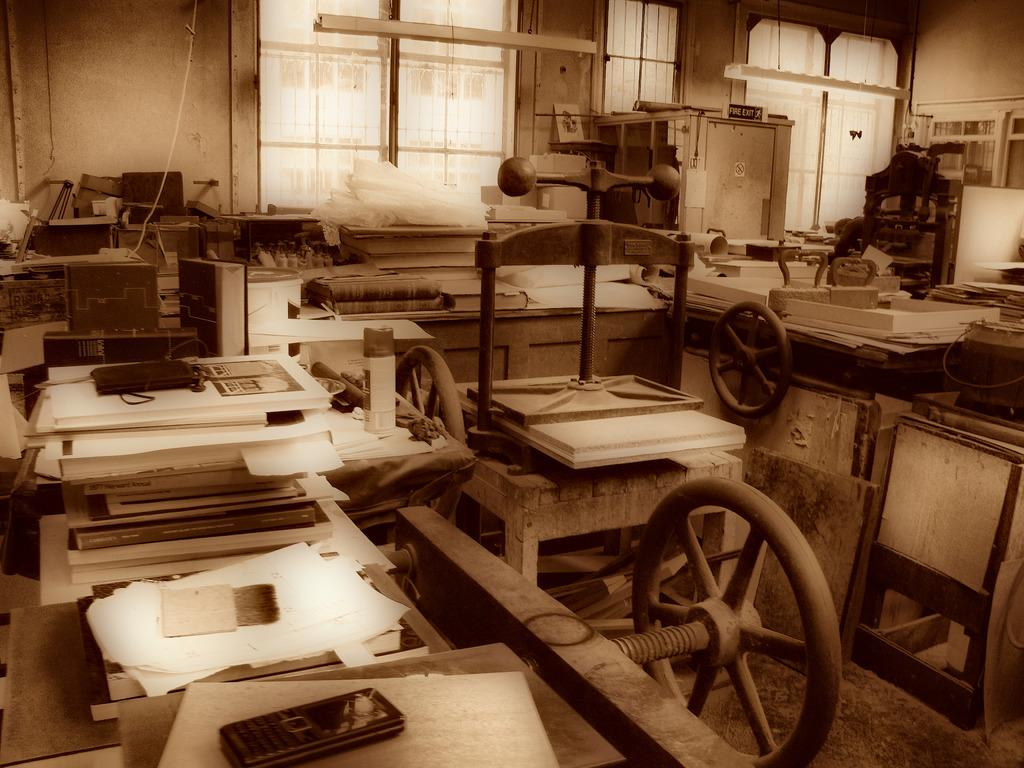What types of objects can be seen in the image? There are machines, wooden objects, papers, and mobile phones in the image. Can you describe the other objects present in the image? There are other objects in the image, but their specific details are not mentioned in the provided facts. What can be seen in the background of the image? Windows and a wall are visible in the background of the image. What type of oil can be seen dripping from the machines in the image? There is no mention of oil or any dripping substance in the image; the machines are not described in such detail. 